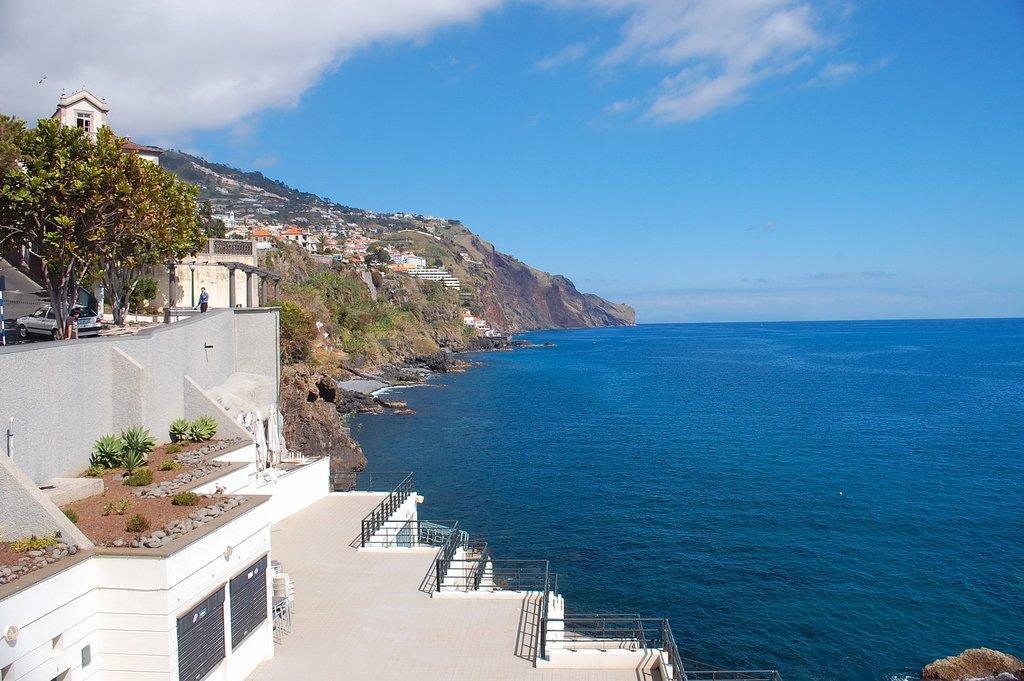In one or two sentences, can you explain what this image depicts? In this image I can see water on the right side. On the left side of the image I can see number of buildings, number of trees, a car and one person. I can also see few plants on the left side. In the background I can see clouds and the sky. 